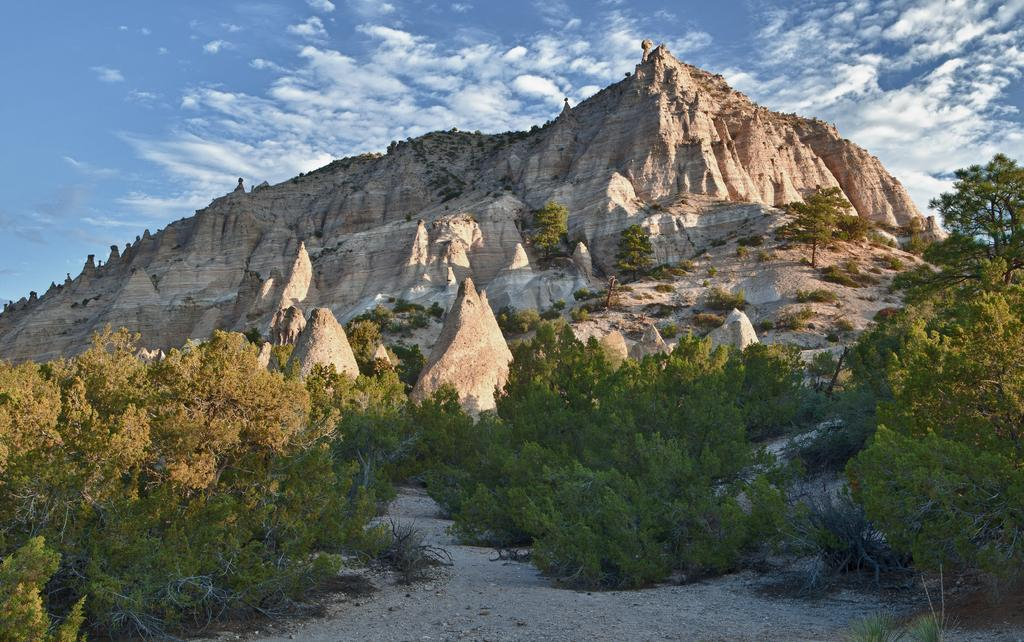What type of vegetation can be seen in the image? There are green plants in the image. What natural landforms are visible in the image? There are mountains visible in the image. What part of the natural environment is visible in the image? The sky is visible in the image. What atmospheric conditions can be observed in the sky? There are clouds in the sky. What type of glass can be seen in the image? There is no glass present in the image. How many bikes are visible in the image? There are no bikes present in the image. 